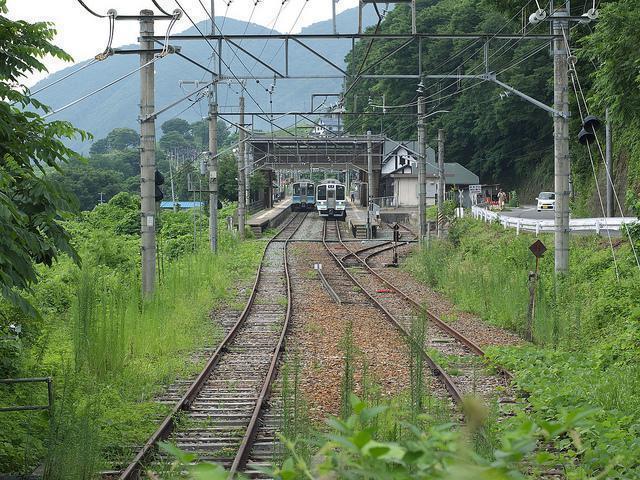There are two trains going down the rail of likely what country?
Indicate the correct response and explain using: 'Answer: answer
Rationale: rationale.'
Options: Korea, canada, united states, japan. Answer: japan.
Rationale: This asian country uses trains on its hilly terrain. How many trains could be traveling underneath of these wires overhanging the train track?
Select the accurate response from the four choices given to answer the question.
Options: Four, three, two, five. Two. 